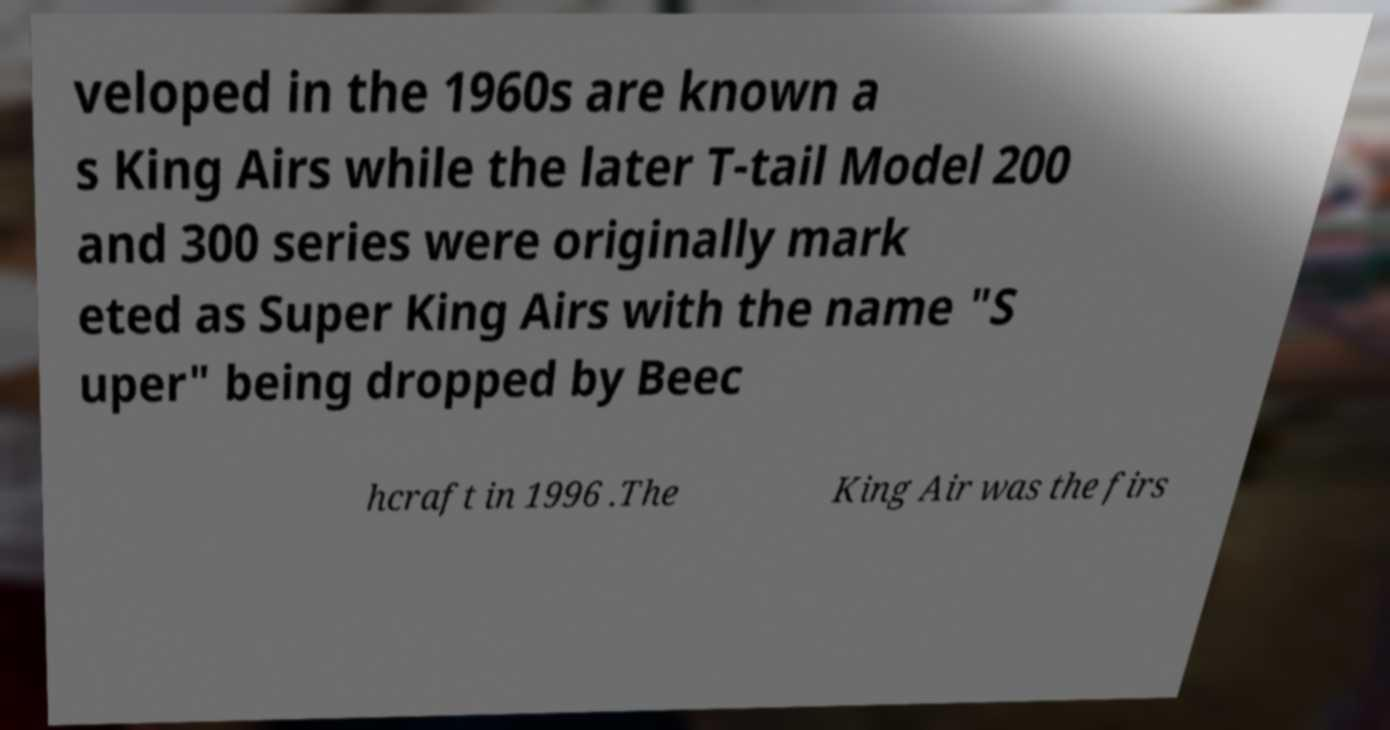Could you assist in decoding the text presented in this image and type it out clearly? veloped in the 1960s are known a s King Airs while the later T-tail Model 200 and 300 series were originally mark eted as Super King Airs with the name "S uper" being dropped by Beec hcraft in 1996 .The King Air was the firs 